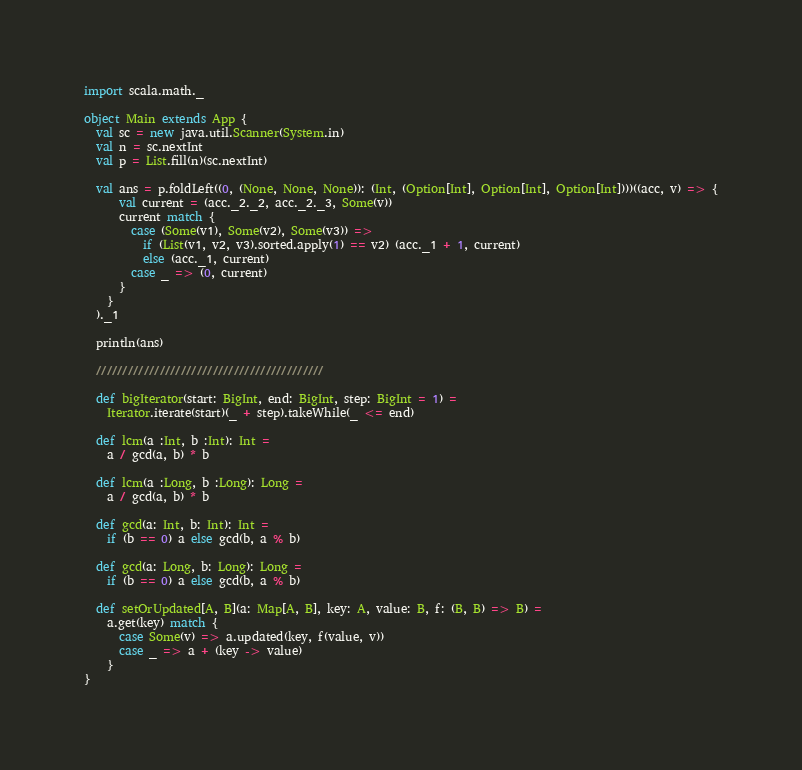Convert code to text. <code><loc_0><loc_0><loc_500><loc_500><_Scala_>import scala.math._

object Main extends App {
  val sc = new java.util.Scanner(System.in)
  val n = sc.nextInt
  val p = List.fill(n)(sc.nextInt)

  val ans = p.foldLeft((0, (None, None, None)): (Int, (Option[Int], Option[Int], Option[Int])))((acc, v) => {
      val current = (acc._2._2, acc._2._3, Some(v))
      current match {
        case (Some(v1), Some(v2), Some(v3)) =>
          if (List(v1, v2, v3).sorted.apply(1) == v2) (acc._1 + 1, current)
          else (acc._1, current)
        case _ => (0, current)
      }
    }
  )._1

  println(ans)

  ///////////////////////////////////////////

  def bigIterator(start: BigInt, end: BigInt, step: BigInt = 1) =
    Iterator.iterate(start)(_ + step).takeWhile(_ <= end)

  def lcm(a :Int, b :Int): Int =
    a / gcd(a, b) * b

  def lcm(a :Long, b :Long): Long =
    a / gcd(a, b) * b

  def gcd(a: Int, b: Int): Int =
    if (b == 0) a else gcd(b, a % b)

  def gcd(a: Long, b: Long): Long =
    if (b == 0) a else gcd(b, a % b)

  def setOrUpdated[A, B](a: Map[A, B], key: A, value: B, f: (B, B) => B) =
    a.get(key) match {
      case Some(v) => a.updated(key, f(value, v))
      case _ => a + (key -> value)
    }
}</code> 